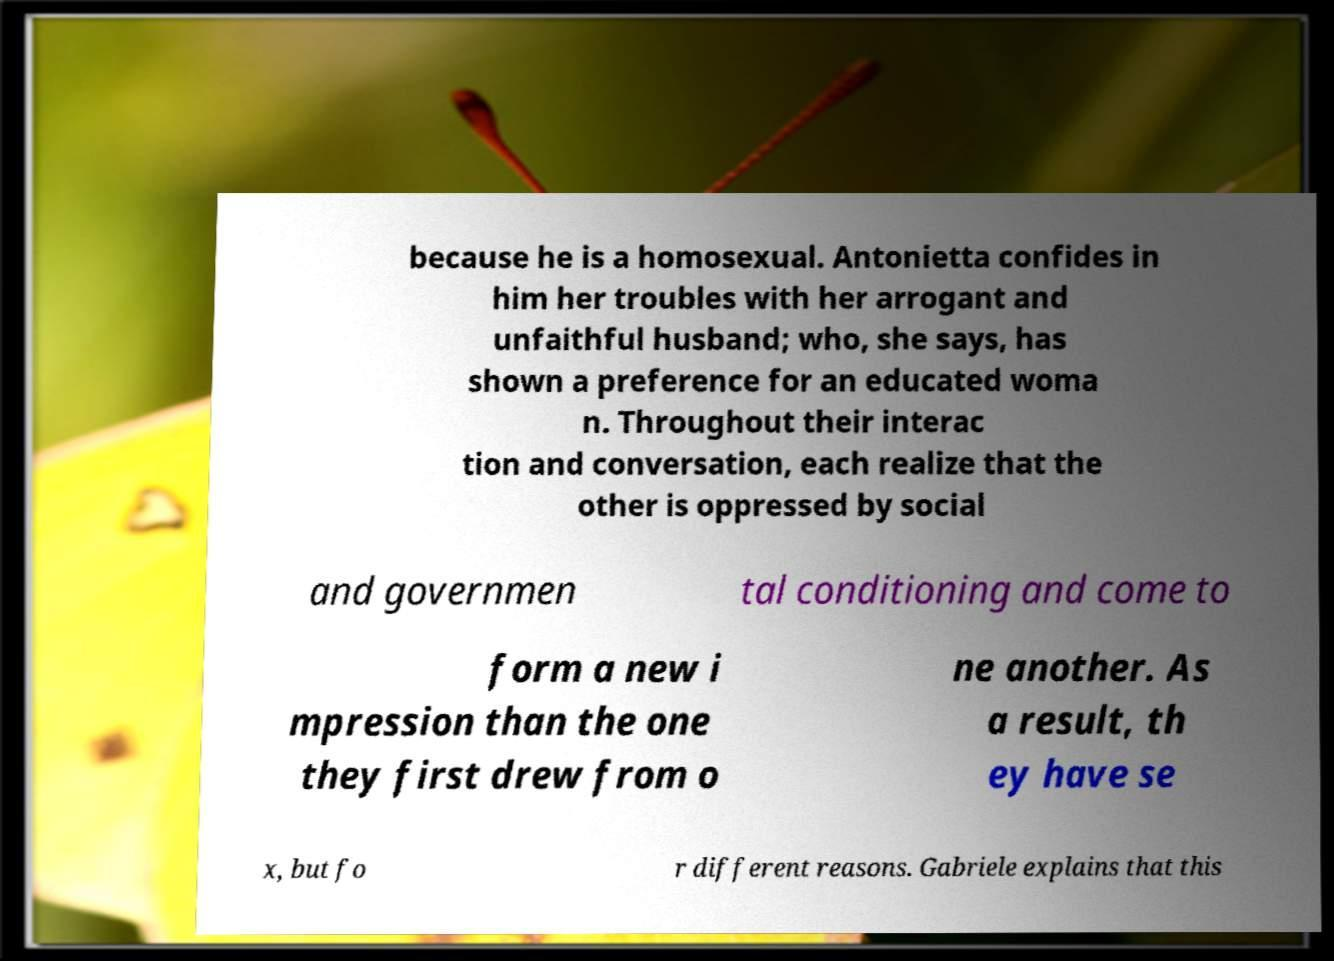Can you read and provide the text displayed in the image?This photo seems to have some interesting text. Can you extract and type it out for me? because he is a homosexual. Antonietta confides in him her troubles with her arrogant and unfaithful husband; who, she says, has shown a preference for an educated woma n. Throughout their interac tion and conversation, each realize that the other is oppressed by social and governmen tal conditioning and come to form a new i mpression than the one they first drew from o ne another. As a result, th ey have se x, but fo r different reasons. Gabriele explains that this 